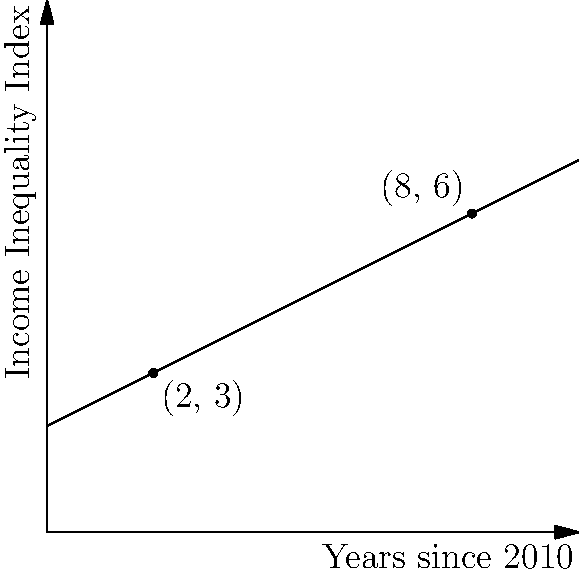The graph shows the trend of income inequality in your city over time. The x-axis represents years since 2010, and the y-axis represents an Income Inequality Index. Calculate the slope of the line connecting the points (2, 3) and (8, 6). What does this slope represent in the context of income inequality? To calculate the slope of the line, we'll use the slope formula:

$$ \text{Slope} = \frac{y_2 - y_1}{x_2 - x_1} $$

Where $(x_1, y_1)$ is the first point and $(x_2, y_2)$ is the second point.

Step 1: Identify the coordinates
$(x_1, y_1) = (2, 3)$
$(x_2, y_2) = (8, 6)$

Step 2: Apply the slope formula
$$ \text{Slope} = \frac{6 - 3}{8 - 2} = \frac{3}{6} = 0.5 $$

Step 3: Interpret the result
The slope is 0.5, which means for each year that passes, the Income Inequality Index increases by 0.5 units.

In the context of income inequality, this positive slope indicates that income inequality is increasing over time. Specifically, for each year that passes, the measure of income inequality in the city increases by 0.5 units on the Income Inequality Index.
Answer: 0.5; represents annual increase in Income Inequality Index 